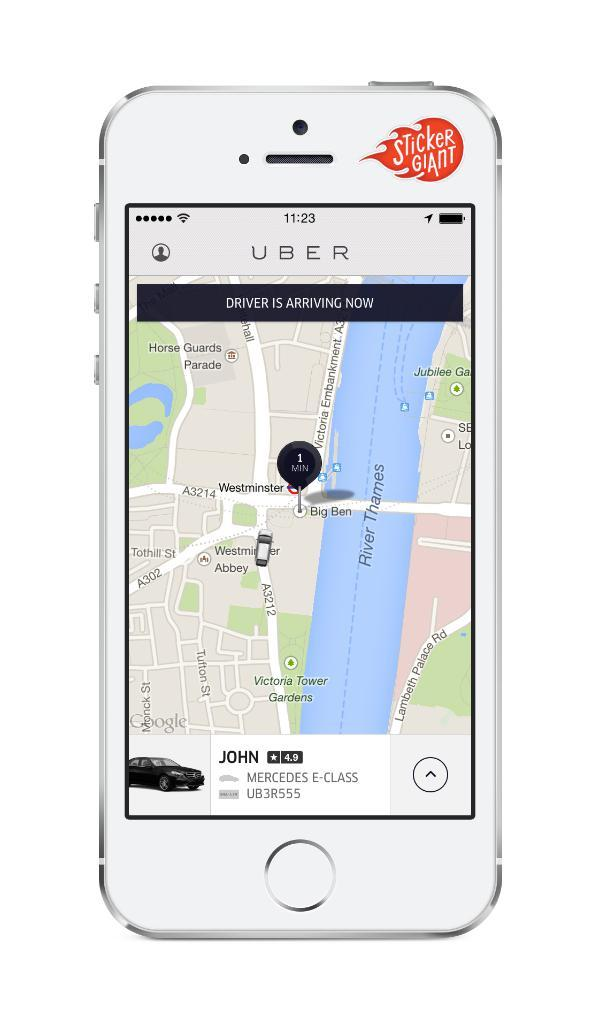What electronic device is visible in the image? There is a mobile phone in the image. Can you describe the appearance of the mobile phone? The appearance of the mobile phone cannot be determined from the image alone. What might the mobile phone be used for in the image? The mobile phone might be used for communication, taking photos, or accessing the internet. Is the mobile phone connected to a chain in the image? There is no chain present in the image, and therefore the mobile phone is not connected to one. 